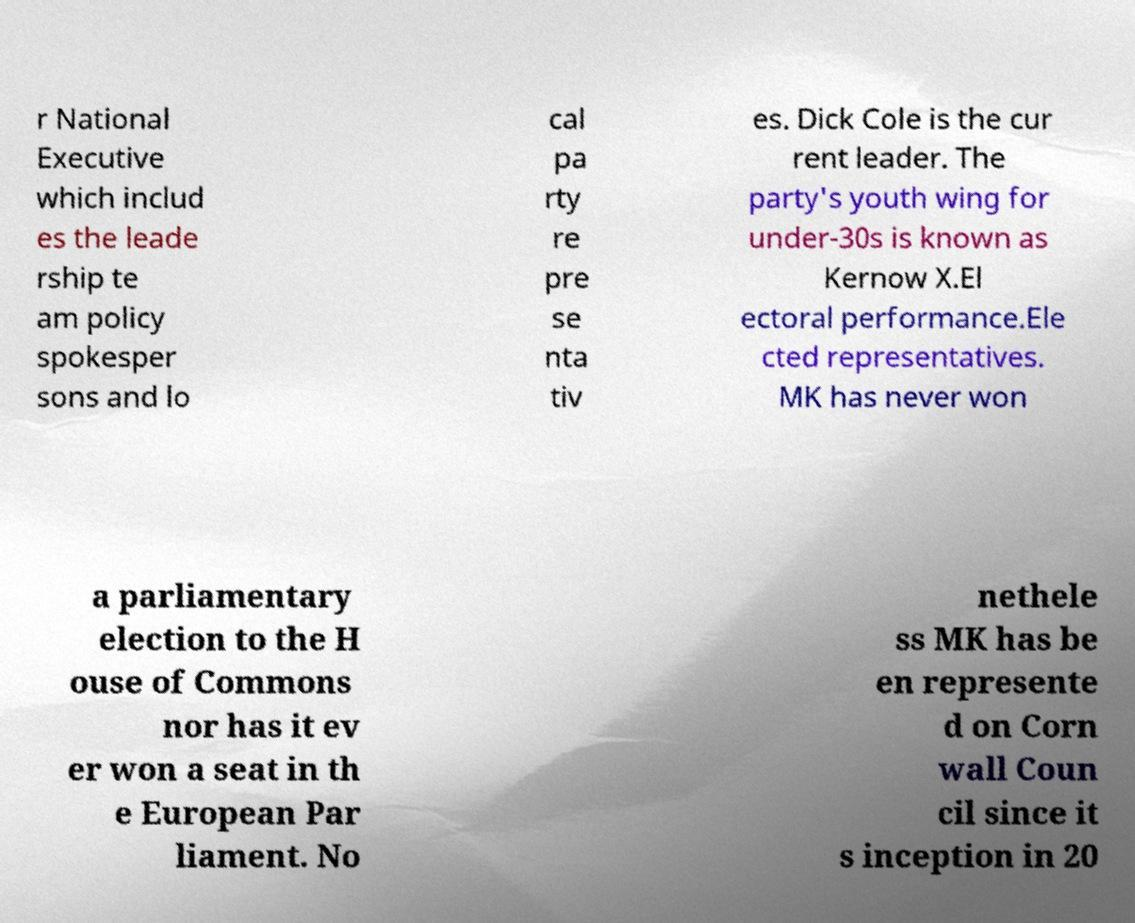For documentation purposes, I need the text within this image transcribed. Could you provide that? r National Executive which includ es the leade rship te am policy spokesper sons and lo cal pa rty re pre se nta tiv es. Dick Cole is the cur rent leader. The party's youth wing for under-30s is known as Kernow X.El ectoral performance.Ele cted representatives. MK has never won a parliamentary election to the H ouse of Commons nor has it ev er won a seat in th e European Par liament. No nethele ss MK has be en represente d on Corn wall Coun cil since it s inception in 20 